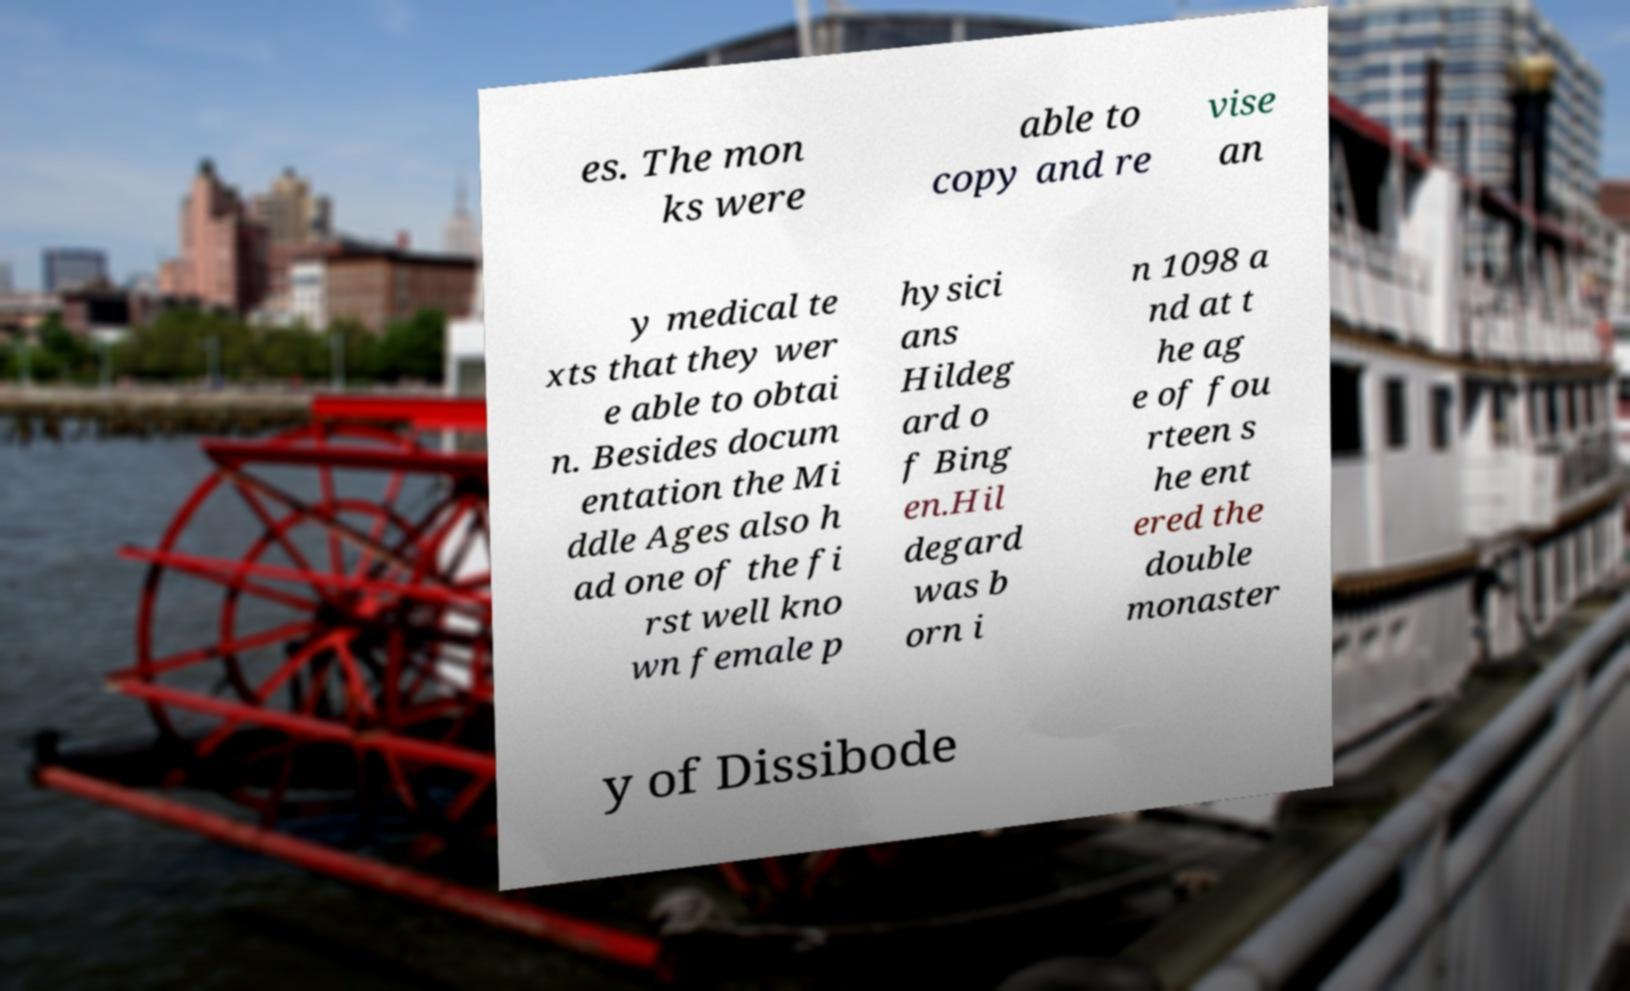What messages or text are displayed in this image? I need them in a readable, typed format. es. The mon ks were able to copy and re vise an y medical te xts that they wer e able to obtai n. Besides docum entation the Mi ddle Ages also h ad one of the fi rst well kno wn female p hysici ans Hildeg ard o f Bing en.Hil degard was b orn i n 1098 a nd at t he ag e of fou rteen s he ent ered the double monaster y of Dissibode 